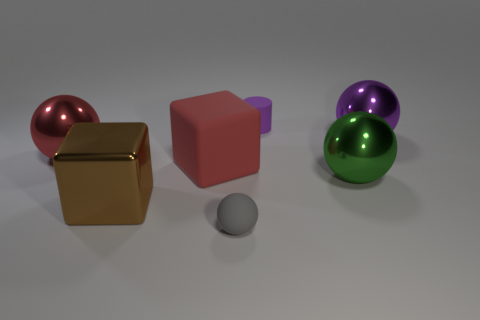Add 3 large green metallic things. How many objects exist? 10 Subtract all spheres. How many objects are left? 3 Add 3 tiny gray rubber things. How many tiny gray rubber things exist? 4 Subtract 0 green cylinders. How many objects are left? 7 Subtract all purple spheres. Subtract all big green metal balls. How many objects are left? 5 Add 3 large red shiny spheres. How many large red shiny spheres are left? 4 